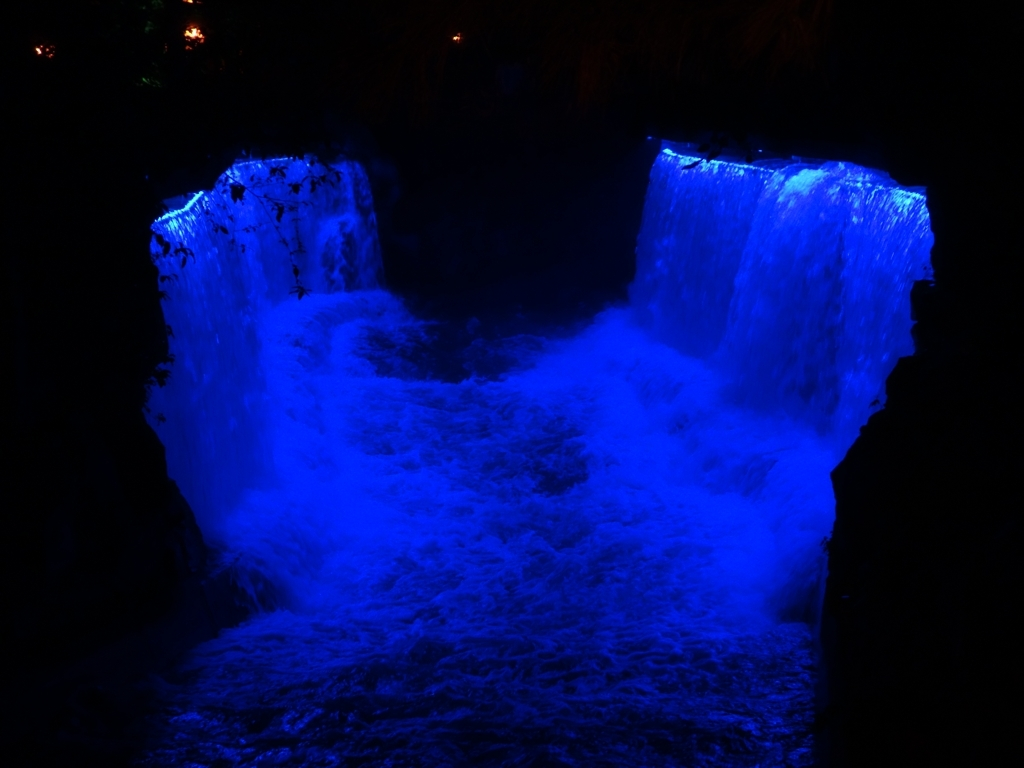Could you describe the surrounding environment of the waterfall? In this image, the surroundings of the waterfall are shrouded in darkness, which suggests that the photo was taken at night. The absence of visible flora or fauna gives the waterfall a stark, isolated presence, with the blue illumination further separating it from any natural context. Are there any human-made structures visible or is this a completely natural setting? From what the image reveals, no human-made structures can be discerned, suggesting that the focus is entirely on the natural element of the waterfall and its unique lighting. Without further context, it's challenging to determine whether the waterfall is in a secluded wilderness or part of a designed landscape. 